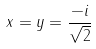<formula> <loc_0><loc_0><loc_500><loc_500>x = y = \frac { - i } { \sqrt { 2 } }</formula> 